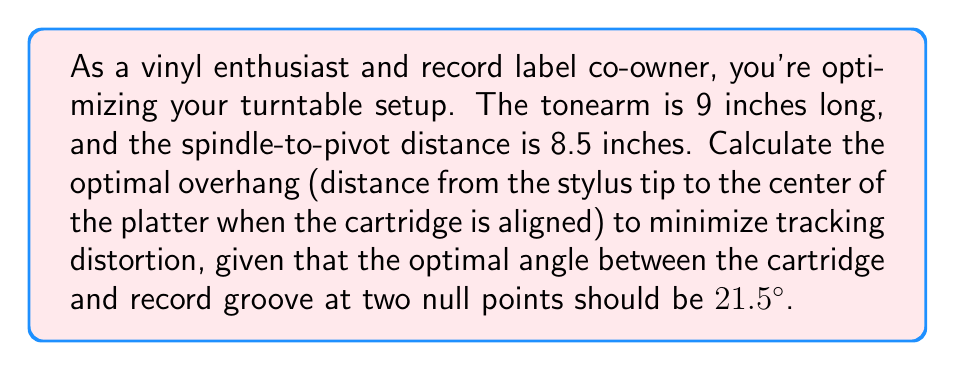Could you help me with this problem? Let's approach this step-by-step:

1) We'll use the Löfgren A alignment, which sets two null points where tracking distortion is zero.

2) The optimal overhang can be calculated using the formula:

   $$\text{Overhang} = L - \sqrt{L^2 - (\frac{d}{2})^2}$$

   Where:
   $L$ = Effective length of tonearm (pivot to stylus)
   $d$ = Spindle-to-pivot distance

3) We need to find $L$. We can use the given angle (21.5°) and the spindle-to-pivot distance to calculate this:

   $$L = \frac{d}{2\sin(\theta)}$$

   Where $\theta$ is half of the given angle (21.5° / 2 = 10.75°)

4) Let's calculate $L$:

   $$L = \frac{8.5}{2\sin(10.75°)} \approx 22.72 \text{ inches}$$

5) Now we can calculate the overhang:

   $$\text{Overhang} = 22.72 - \sqrt{22.72^2 - (\frac{8.5}{2})^2}$$

6) Simplifying:

   $$\text{Overhang} = 22.72 - \sqrt{516.20 - 18.0625} \approx 0.73 \text{ inches}$$

Thus, the optimal overhang is approximately 0.73 inches or 18.5 mm.
Answer: 0.73 inches (18.5 mm) 